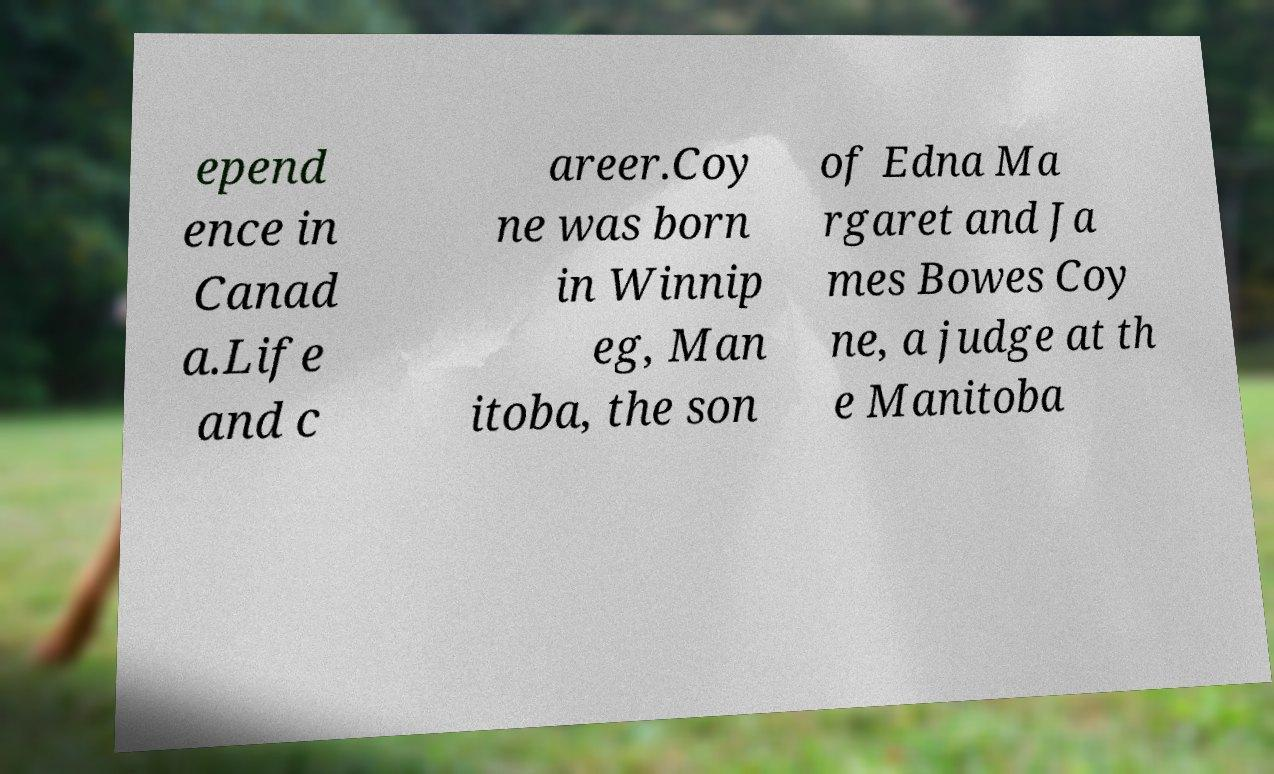Please identify and transcribe the text found in this image. epend ence in Canad a.Life and c areer.Coy ne was born in Winnip eg, Man itoba, the son of Edna Ma rgaret and Ja mes Bowes Coy ne, a judge at th e Manitoba 